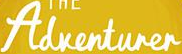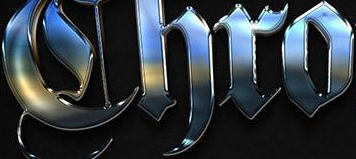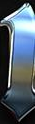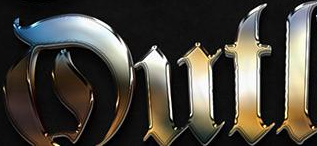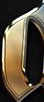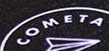Read the text from these images in sequence, separated by a semicolon. Adventurer; Chro; #; Dutl; #; COMETA 